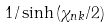<formula> <loc_0><loc_0><loc_500><loc_500>1 / \sinh { ( \chi _ { n k } / 2 ) }</formula> 